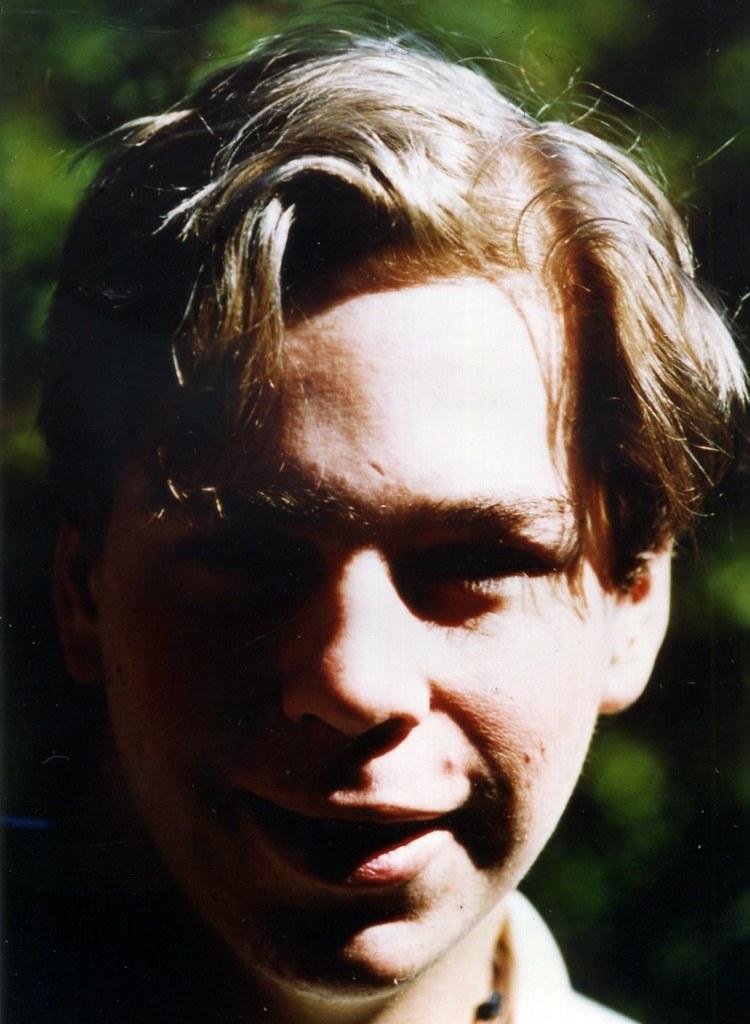Can you describe this image briefly? In this picture we can see the close view of the boy face, smiling and giving a pose to the camera. Behind there is a green blur background. 